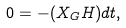Convert formula to latex. <formula><loc_0><loc_0><loc_500><loc_500>0 = - ( X _ { G } H ) d t ,</formula> 